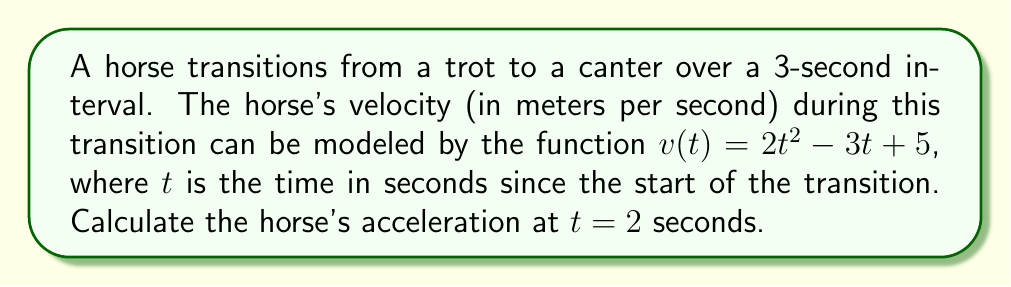Could you help me with this problem? To solve this problem, we need to follow these steps:

1) Recall that acceleration is the derivative of velocity with respect to time. In mathematical terms:

   $a(t) = \frac{dv}{dt}$

2) We are given the velocity function:

   $v(t) = 2t^2 - 3t + 5$

3) To find the acceleration function, we need to differentiate $v(t)$ with respect to $t$:

   $a(t) = \frac{d}{dt}(2t^2 - 3t + 5)$

4) Using the power rule and the constant rule of differentiation:

   $a(t) = 4t - 3$

5) Now that we have the acceleration function, we can find the acceleration at $t = 2$ seconds by substituting $t = 2$ into our acceleration function:

   $a(2) = 4(2) - 3$
   
   $a(2) = 8 - 3 = 5$

Therefore, the horse's acceleration at $t = 2$ seconds is 5 m/s².
Answer: 5 m/s² 